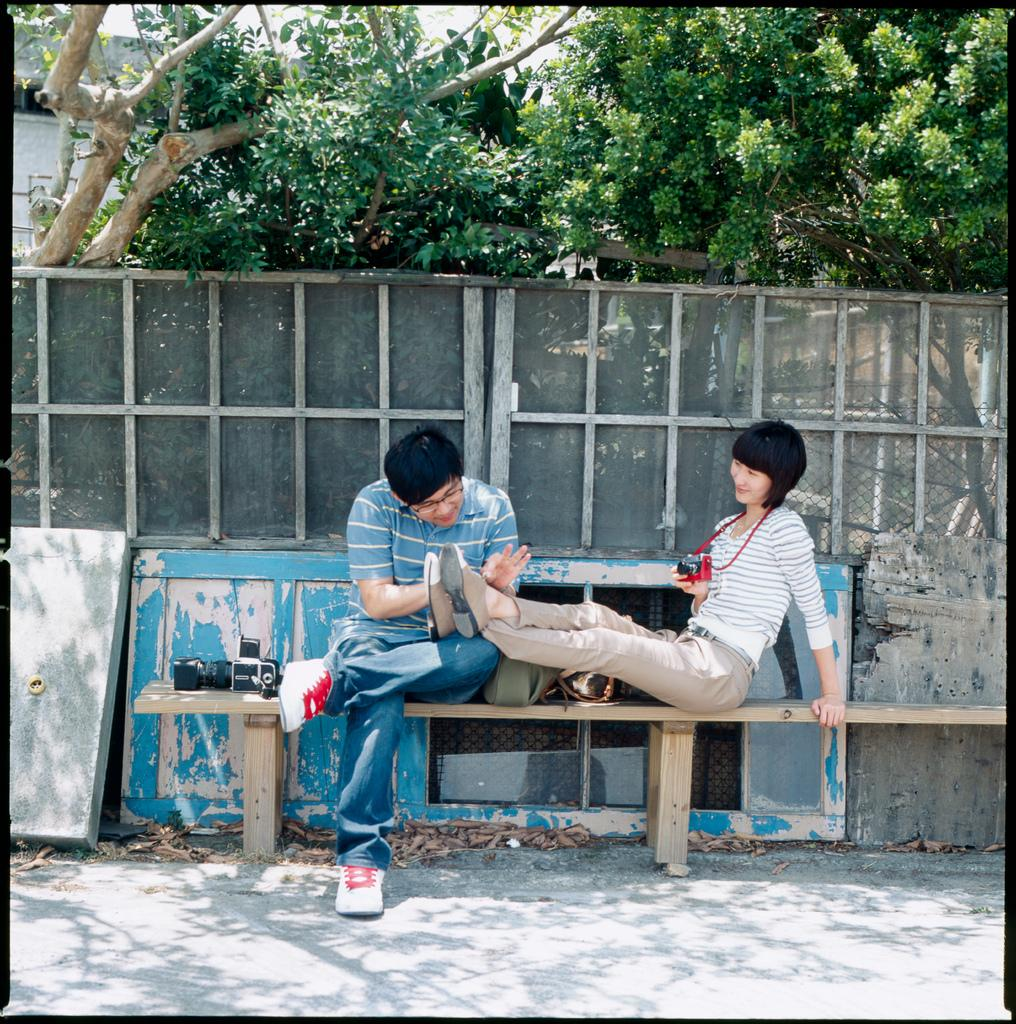What type of vegetation can be seen in the image? There are trees in the image. What type of seating is present in the image? There is a bench in the image. How many people are sitting on the bench? Two people are sitting on the bench. What color is the sweater worn by the foot in the image? There is no foot or sweater present in the image. What type of humor can be observed in the image? There is no humor depicted in the image; it features trees, a bench, and two people sitting on the bench. 